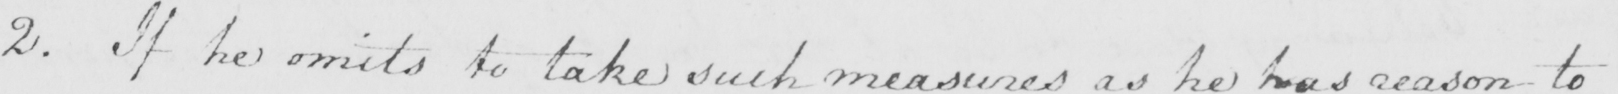Can you tell me what this handwritten text says? 2 . If he omits to take such measures as he has reason to 